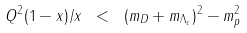<formula> <loc_0><loc_0><loc_500><loc_500>Q ^ { 2 } ( 1 - x ) / x \ < \ ( m _ { D } + m _ { \Lambda _ { c } } ) ^ { 2 } - m _ { p } ^ { 2 }</formula> 